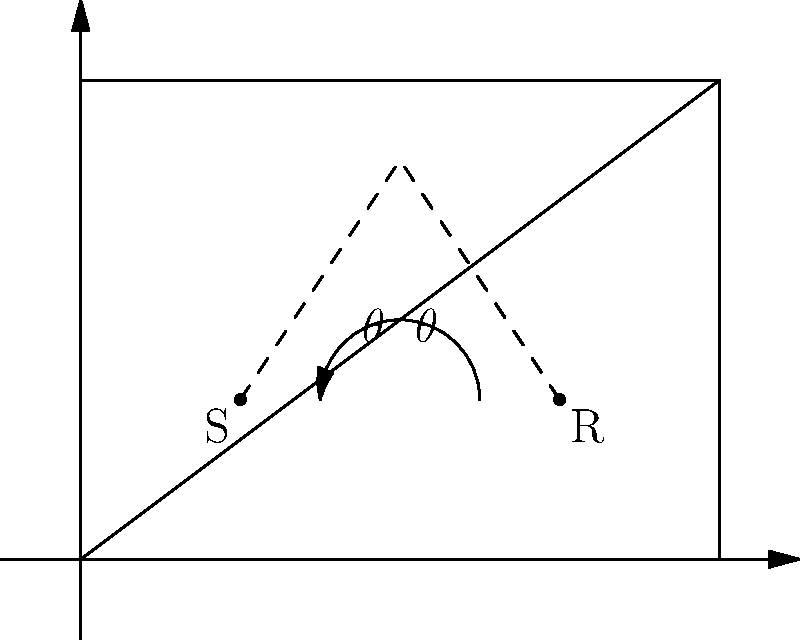In a rectangular recording studio, a sound wave travels from the singer (S) to a wall and then reflects to the microphone (R). If the angle of incidence equals the angle of reflection, and the path S-N-R forms an isosceles triangle where N is the point of reflection on the wall, what is the measure of angle $\theta$ (in degrees) formed between the incident sound wave and the wall? Let's approach this step-by-step:

1) In the diagram, S-N-R forms an isosceles triangle, with SN = NR.

2) The line M-N bisects the angle SNR, where M is the midpoint of SR.

3) The angle of incidence equals the angle of reflection, both represented by $\theta$.

4) In the right triangle formed by the wall and M-N:
   - The base angle is $\theta$
   - The right angle is 90°

5) The sum of angles in a triangle is 180°. So:
   $\theta + 90° + \theta = 180°$

6) Simplifying:
   $2\theta + 90° = 180°$
   $2\theta = 90°$

7) Solving for $\theta$:
   $\theta = 45°$

Therefore, the angle between the incident sound wave and the wall is 45°.
Answer: 45° 